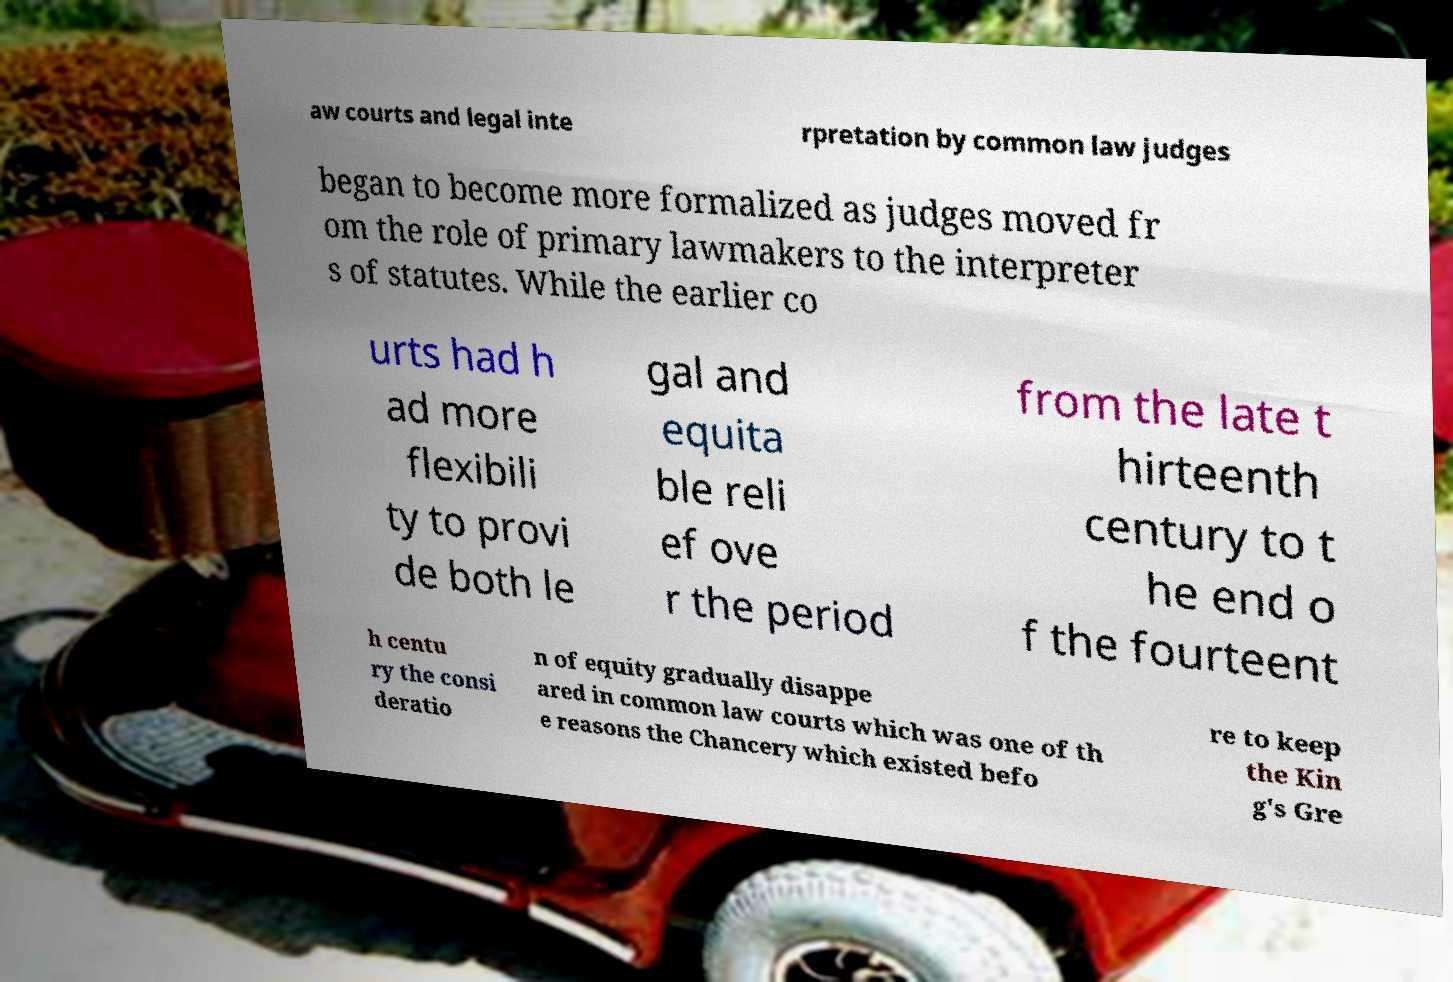What messages or text are displayed in this image? I need them in a readable, typed format. aw courts and legal inte rpretation by common law judges began to become more formalized as judges moved fr om the role of primary lawmakers to the interpreter s of statutes. While the earlier co urts had h ad more flexibili ty to provi de both le gal and equita ble reli ef ove r the period from the late t hirteenth century to t he end o f the fourteent h centu ry the consi deratio n of equity gradually disappe ared in common law courts which was one of th e reasons the Chancery which existed befo re to keep the Kin g's Gre 